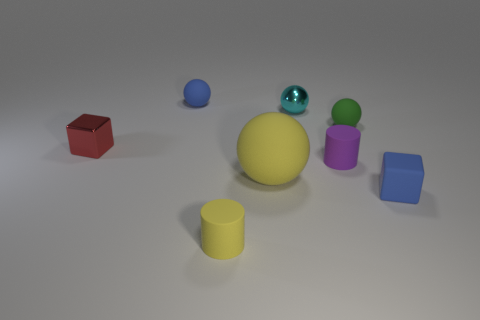Are there any other things that are the same size as the yellow sphere?
Your response must be concise. No. The cylinder that is the same color as the big matte ball is what size?
Your answer should be very brief. Small. Is the number of cyan metal spheres greater than the number of yellow matte things?
Provide a short and direct response. No. How many tiny blue rubber spheres are in front of the big matte thing that is on the left side of the blue rubber object that is in front of the large rubber object?
Your answer should be compact. 0. There is a tiny yellow object; what shape is it?
Your answer should be very brief. Cylinder. What number of other things are there of the same material as the yellow cylinder
Provide a short and direct response. 5. Is the red thing the same size as the cyan metallic sphere?
Your response must be concise. Yes. There is a tiny object that is to the left of the blue sphere; what shape is it?
Make the answer very short. Cube. What is the color of the tiny cylinder that is to the right of the matte object that is in front of the rubber cube?
Your answer should be compact. Purple. There is a blue matte thing in front of the small metallic ball; does it have the same shape as the tiny blue object behind the large sphere?
Provide a short and direct response. No. 